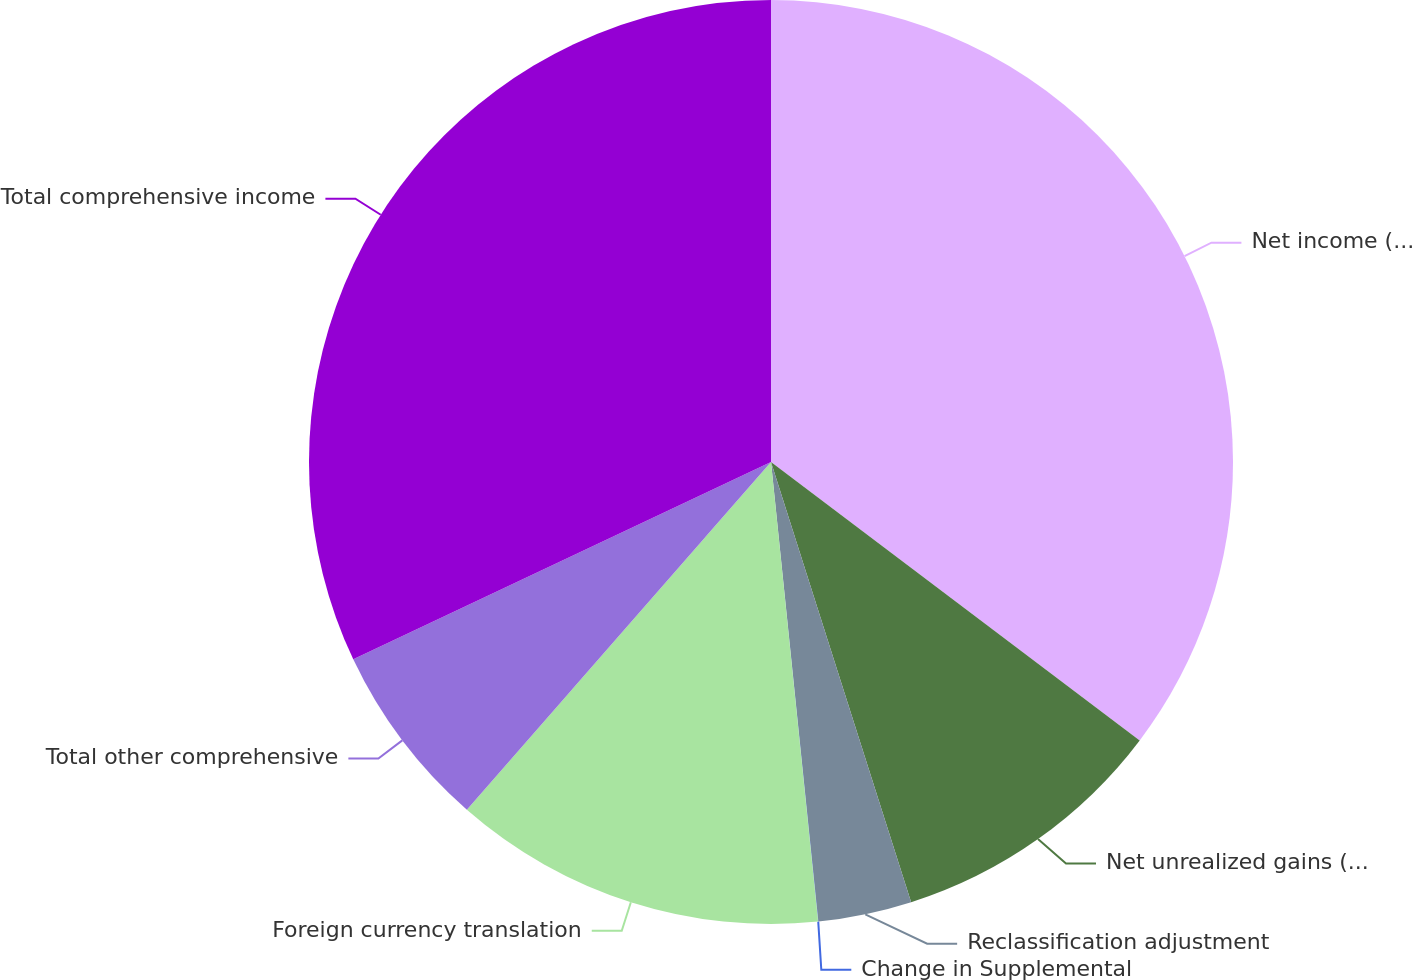<chart> <loc_0><loc_0><loc_500><loc_500><pie_chart><fcel>Net income (loss)<fcel>Net unrealized gains (losses)<fcel>Reclassification adjustment<fcel>Change in Supplemental<fcel>Foreign currency translation<fcel>Total other comprehensive<fcel>Total comprehensive income<nl><fcel>35.29%<fcel>9.8%<fcel>3.27%<fcel>0.01%<fcel>13.06%<fcel>6.54%<fcel>32.02%<nl></chart> 